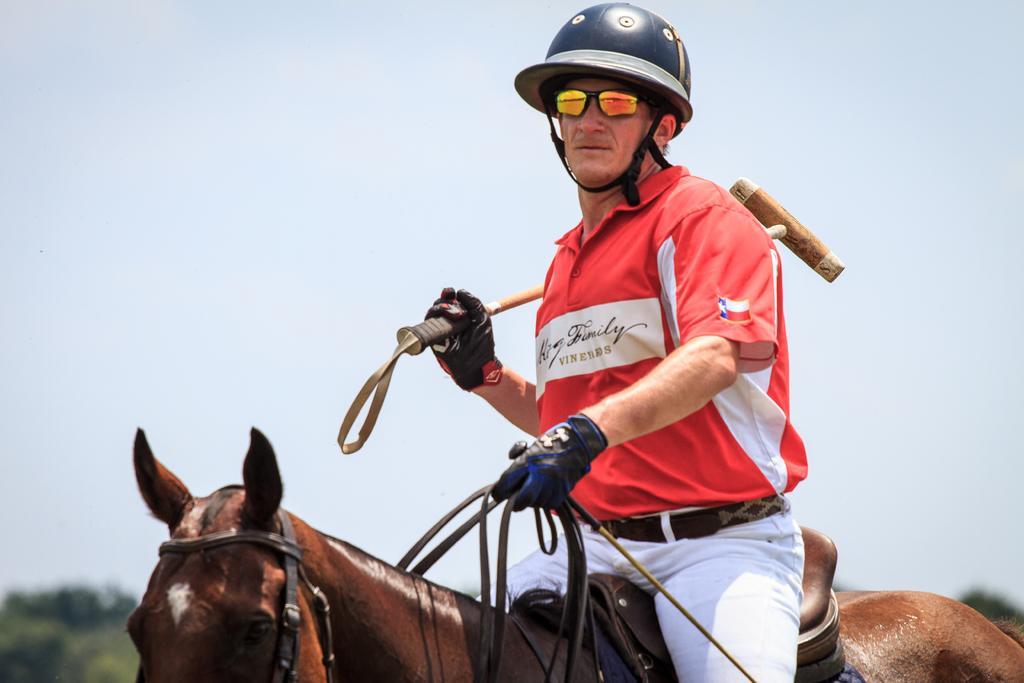Please provide a concise description of this image. In this image in the foreground there is a man sitting on the horse and the background is the sky. 